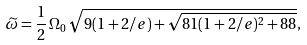<formula> <loc_0><loc_0><loc_500><loc_500>\widetilde { \omega } = \frac { 1 } { 2 } \, \Omega _ { 0 } \, \sqrt { 9 ( 1 + 2 / e ) + \sqrt { 8 1 ( 1 + 2 / e ) ^ { 2 } + 8 8 } } ,</formula> 